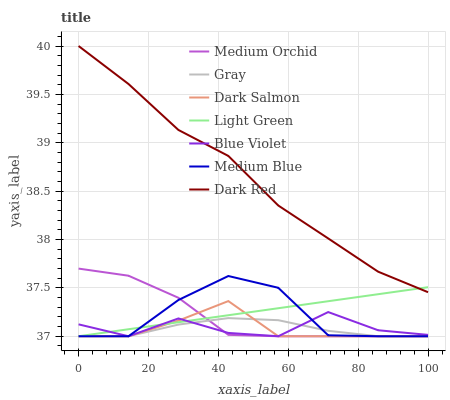Does Dark Salmon have the minimum area under the curve?
Answer yes or no. Yes. Does Dark Red have the maximum area under the curve?
Answer yes or no. Yes. Does Medium Orchid have the minimum area under the curve?
Answer yes or no. No. Does Medium Orchid have the maximum area under the curve?
Answer yes or no. No. Is Light Green the smoothest?
Answer yes or no. Yes. Is Medium Blue the roughest?
Answer yes or no. Yes. Is Dark Red the smoothest?
Answer yes or no. No. Is Dark Red the roughest?
Answer yes or no. No. Does Gray have the lowest value?
Answer yes or no. Yes. Does Dark Red have the lowest value?
Answer yes or no. No. Does Dark Red have the highest value?
Answer yes or no. Yes. Does Medium Orchid have the highest value?
Answer yes or no. No. Is Gray less than Dark Red?
Answer yes or no. Yes. Is Dark Red greater than Medium Blue?
Answer yes or no. Yes. Does Light Green intersect Dark Red?
Answer yes or no. Yes. Is Light Green less than Dark Red?
Answer yes or no. No. Is Light Green greater than Dark Red?
Answer yes or no. No. Does Gray intersect Dark Red?
Answer yes or no. No. 